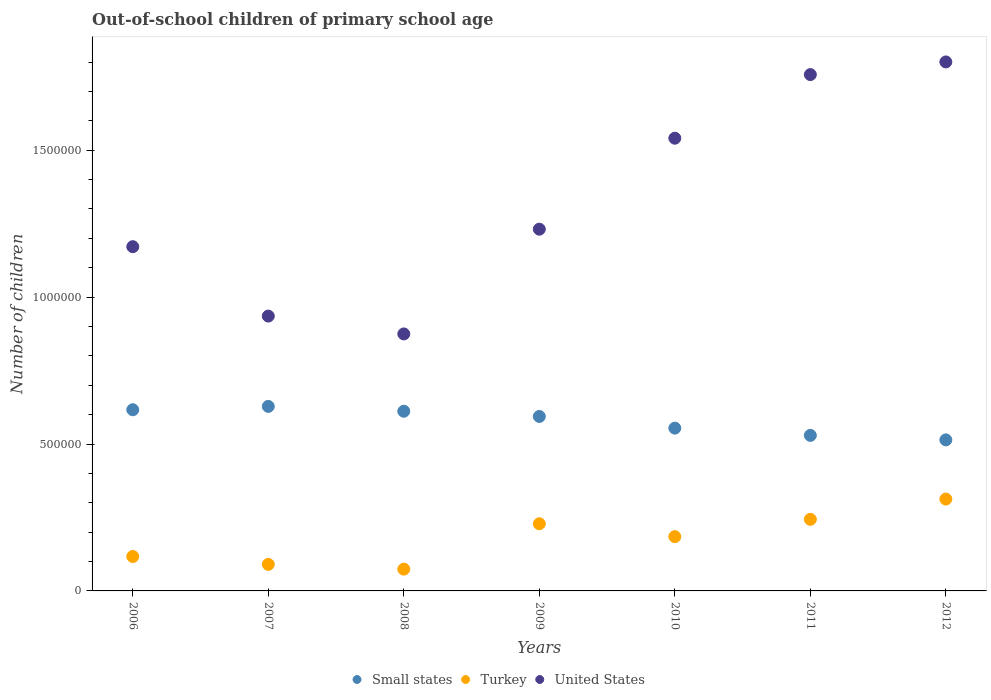Is the number of dotlines equal to the number of legend labels?
Offer a terse response. Yes. What is the number of out-of-school children in Small states in 2008?
Provide a succinct answer. 6.12e+05. Across all years, what is the maximum number of out-of-school children in United States?
Your response must be concise. 1.80e+06. Across all years, what is the minimum number of out-of-school children in Small states?
Offer a terse response. 5.14e+05. In which year was the number of out-of-school children in Small states minimum?
Provide a succinct answer. 2012. What is the total number of out-of-school children in United States in the graph?
Keep it short and to the point. 9.31e+06. What is the difference between the number of out-of-school children in Small states in 2006 and that in 2010?
Your answer should be compact. 6.25e+04. What is the difference between the number of out-of-school children in United States in 2009 and the number of out-of-school children in Small states in 2008?
Make the answer very short. 6.20e+05. What is the average number of out-of-school children in United States per year?
Offer a very short reply. 1.33e+06. In the year 2012, what is the difference between the number of out-of-school children in United States and number of out-of-school children in Small states?
Keep it short and to the point. 1.29e+06. In how many years, is the number of out-of-school children in Small states greater than 700000?
Provide a succinct answer. 0. What is the ratio of the number of out-of-school children in Small states in 2007 to that in 2011?
Your answer should be compact. 1.19. Is the number of out-of-school children in Turkey in 2011 less than that in 2012?
Your answer should be very brief. Yes. What is the difference between the highest and the second highest number of out-of-school children in United States?
Provide a short and direct response. 4.31e+04. What is the difference between the highest and the lowest number of out-of-school children in United States?
Make the answer very short. 9.26e+05. In how many years, is the number of out-of-school children in Turkey greater than the average number of out-of-school children in Turkey taken over all years?
Give a very brief answer. 4. Is the number of out-of-school children in Small states strictly greater than the number of out-of-school children in Turkey over the years?
Your response must be concise. Yes. How many years are there in the graph?
Offer a very short reply. 7. What is the difference between two consecutive major ticks on the Y-axis?
Keep it short and to the point. 5.00e+05. Are the values on the major ticks of Y-axis written in scientific E-notation?
Make the answer very short. No. Does the graph contain grids?
Your answer should be very brief. No. Where does the legend appear in the graph?
Give a very brief answer. Bottom center. How many legend labels are there?
Your answer should be compact. 3. What is the title of the graph?
Ensure brevity in your answer.  Out-of-school children of primary school age. Does "Mozambique" appear as one of the legend labels in the graph?
Ensure brevity in your answer.  No. What is the label or title of the Y-axis?
Provide a short and direct response. Number of children. What is the Number of children of Small states in 2006?
Your response must be concise. 6.17e+05. What is the Number of children of Turkey in 2006?
Your answer should be compact. 1.17e+05. What is the Number of children in United States in 2006?
Keep it short and to the point. 1.17e+06. What is the Number of children in Small states in 2007?
Provide a succinct answer. 6.28e+05. What is the Number of children in Turkey in 2007?
Offer a terse response. 9.04e+04. What is the Number of children of United States in 2007?
Offer a very short reply. 9.35e+05. What is the Number of children of Small states in 2008?
Keep it short and to the point. 6.12e+05. What is the Number of children of Turkey in 2008?
Give a very brief answer. 7.42e+04. What is the Number of children in United States in 2008?
Your answer should be very brief. 8.75e+05. What is the Number of children of Small states in 2009?
Your response must be concise. 5.94e+05. What is the Number of children of Turkey in 2009?
Offer a very short reply. 2.29e+05. What is the Number of children of United States in 2009?
Your response must be concise. 1.23e+06. What is the Number of children in Small states in 2010?
Your answer should be very brief. 5.54e+05. What is the Number of children of Turkey in 2010?
Offer a very short reply. 1.85e+05. What is the Number of children of United States in 2010?
Offer a terse response. 1.54e+06. What is the Number of children of Small states in 2011?
Provide a short and direct response. 5.29e+05. What is the Number of children of Turkey in 2011?
Give a very brief answer. 2.44e+05. What is the Number of children of United States in 2011?
Keep it short and to the point. 1.76e+06. What is the Number of children of Small states in 2012?
Provide a succinct answer. 5.14e+05. What is the Number of children in Turkey in 2012?
Ensure brevity in your answer.  3.13e+05. What is the Number of children in United States in 2012?
Your response must be concise. 1.80e+06. Across all years, what is the maximum Number of children of Small states?
Your answer should be very brief. 6.28e+05. Across all years, what is the maximum Number of children of Turkey?
Your answer should be very brief. 3.13e+05. Across all years, what is the maximum Number of children of United States?
Your answer should be compact. 1.80e+06. Across all years, what is the minimum Number of children in Small states?
Your response must be concise. 5.14e+05. Across all years, what is the minimum Number of children in Turkey?
Ensure brevity in your answer.  7.42e+04. Across all years, what is the minimum Number of children of United States?
Give a very brief answer. 8.75e+05. What is the total Number of children of Small states in the graph?
Give a very brief answer. 4.05e+06. What is the total Number of children of Turkey in the graph?
Your response must be concise. 1.25e+06. What is the total Number of children of United States in the graph?
Keep it short and to the point. 9.31e+06. What is the difference between the Number of children of Small states in 2006 and that in 2007?
Ensure brevity in your answer.  -1.14e+04. What is the difference between the Number of children in Turkey in 2006 and that in 2007?
Ensure brevity in your answer.  2.67e+04. What is the difference between the Number of children in United States in 2006 and that in 2007?
Provide a short and direct response. 2.36e+05. What is the difference between the Number of children of Small states in 2006 and that in 2008?
Ensure brevity in your answer.  5096. What is the difference between the Number of children in Turkey in 2006 and that in 2008?
Make the answer very short. 4.29e+04. What is the difference between the Number of children in United States in 2006 and that in 2008?
Provide a short and direct response. 2.97e+05. What is the difference between the Number of children of Small states in 2006 and that in 2009?
Make the answer very short. 2.28e+04. What is the difference between the Number of children of Turkey in 2006 and that in 2009?
Offer a very short reply. -1.11e+05. What is the difference between the Number of children in United States in 2006 and that in 2009?
Your answer should be very brief. -5.96e+04. What is the difference between the Number of children in Small states in 2006 and that in 2010?
Keep it short and to the point. 6.25e+04. What is the difference between the Number of children in Turkey in 2006 and that in 2010?
Provide a short and direct response. -6.77e+04. What is the difference between the Number of children in United States in 2006 and that in 2010?
Offer a terse response. -3.69e+05. What is the difference between the Number of children in Small states in 2006 and that in 2011?
Your response must be concise. 8.72e+04. What is the difference between the Number of children in Turkey in 2006 and that in 2011?
Your response must be concise. -1.27e+05. What is the difference between the Number of children in United States in 2006 and that in 2011?
Make the answer very short. -5.86e+05. What is the difference between the Number of children in Small states in 2006 and that in 2012?
Give a very brief answer. 1.03e+05. What is the difference between the Number of children of Turkey in 2006 and that in 2012?
Offer a very short reply. -1.96e+05. What is the difference between the Number of children of United States in 2006 and that in 2012?
Provide a succinct answer. -6.29e+05. What is the difference between the Number of children of Small states in 2007 and that in 2008?
Keep it short and to the point. 1.65e+04. What is the difference between the Number of children of Turkey in 2007 and that in 2008?
Give a very brief answer. 1.62e+04. What is the difference between the Number of children of United States in 2007 and that in 2008?
Offer a very short reply. 6.08e+04. What is the difference between the Number of children of Small states in 2007 and that in 2009?
Provide a succinct answer. 3.42e+04. What is the difference between the Number of children of Turkey in 2007 and that in 2009?
Keep it short and to the point. -1.38e+05. What is the difference between the Number of children in United States in 2007 and that in 2009?
Offer a terse response. -2.96e+05. What is the difference between the Number of children in Small states in 2007 and that in 2010?
Provide a succinct answer. 7.39e+04. What is the difference between the Number of children of Turkey in 2007 and that in 2010?
Ensure brevity in your answer.  -9.43e+04. What is the difference between the Number of children in United States in 2007 and that in 2010?
Your response must be concise. -6.05e+05. What is the difference between the Number of children in Small states in 2007 and that in 2011?
Provide a succinct answer. 9.86e+04. What is the difference between the Number of children of Turkey in 2007 and that in 2011?
Provide a succinct answer. -1.53e+05. What is the difference between the Number of children of United States in 2007 and that in 2011?
Keep it short and to the point. -8.22e+05. What is the difference between the Number of children in Small states in 2007 and that in 2012?
Ensure brevity in your answer.  1.14e+05. What is the difference between the Number of children of Turkey in 2007 and that in 2012?
Keep it short and to the point. -2.22e+05. What is the difference between the Number of children of United States in 2007 and that in 2012?
Give a very brief answer. -8.65e+05. What is the difference between the Number of children in Small states in 2008 and that in 2009?
Offer a very short reply. 1.77e+04. What is the difference between the Number of children of Turkey in 2008 and that in 2009?
Give a very brief answer. -1.54e+05. What is the difference between the Number of children of United States in 2008 and that in 2009?
Make the answer very short. -3.57e+05. What is the difference between the Number of children in Small states in 2008 and that in 2010?
Your answer should be compact. 5.74e+04. What is the difference between the Number of children in Turkey in 2008 and that in 2010?
Give a very brief answer. -1.11e+05. What is the difference between the Number of children in United States in 2008 and that in 2010?
Provide a succinct answer. -6.66e+05. What is the difference between the Number of children in Small states in 2008 and that in 2011?
Ensure brevity in your answer.  8.22e+04. What is the difference between the Number of children in Turkey in 2008 and that in 2011?
Offer a very short reply. -1.70e+05. What is the difference between the Number of children in United States in 2008 and that in 2011?
Your response must be concise. -8.83e+05. What is the difference between the Number of children of Small states in 2008 and that in 2012?
Make the answer very short. 9.74e+04. What is the difference between the Number of children of Turkey in 2008 and that in 2012?
Give a very brief answer. -2.39e+05. What is the difference between the Number of children in United States in 2008 and that in 2012?
Make the answer very short. -9.26e+05. What is the difference between the Number of children of Small states in 2009 and that in 2010?
Your answer should be compact. 3.97e+04. What is the difference between the Number of children in Turkey in 2009 and that in 2010?
Provide a succinct answer. 4.38e+04. What is the difference between the Number of children in United States in 2009 and that in 2010?
Make the answer very short. -3.10e+05. What is the difference between the Number of children in Small states in 2009 and that in 2011?
Your answer should be very brief. 6.44e+04. What is the difference between the Number of children in Turkey in 2009 and that in 2011?
Give a very brief answer. -1.52e+04. What is the difference between the Number of children of United States in 2009 and that in 2011?
Provide a short and direct response. -5.26e+05. What is the difference between the Number of children in Small states in 2009 and that in 2012?
Keep it short and to the point. 7.97e+04. What is the difference between the Number of children of Turkey in 2009 and that in 2012?
Keep it short and to the point. -8.41e+04. What is the difference between the Number of children of United States in 2009 and that in 2012?
Make the answer very short. -5.69e+05. What is the difference between the Number of children of Small states in 2010 and that in 2011?
Give a very brief answer. 2.47e+04. What is the difference between the Number of children in Turkey in 2010 and that in 2011?
Give a very brief answer. -5.90e+04. What is the difference between the Number of children in United States in 2010 and that in 2011?
Ensure brevity in your answer.  -2.17e+05. What is the difference between the Number of children in Small states in 2010 and that in 2012?
Your answer should be compact. 4.00e+04. What is the difference between the Number of children in Turkey in 2010 and that in 2012?
Offer a terse response. -1.28e+05. What is the difference between the Number of children of United States in 2010 and that in 2012?
Your answer should be compact. -2.60e+05. What is the difference between the Number of children in Small states in 2011 and that in 2012?
Your response must be concise. 1.53e+04. What is the difference between the Number of children of Turkey in 2011 and that in 2012?
Offer a terse response. -6.89e+04. What is the difference between the Number of children of United States in 2011 and that in 2012?
Your answer should be compact. -4.31e+04. What is the difference between the Number of children in Small states in 2006 and the Number of children in Turkey in 2007?
Provide a short and direct response. 5.26e+05. What is the difference between the Number of children in Small states in 2006 and the Number of children in United States in 2007?
Your response must be concise. -3.19e+05. What is the difference between the Number of children in Turkey in 2006 and the Number of children in United States in 2007?
Make the answer very short. -8.18e+05. What is the difference between the Number of children of Small states in 2006 and the Number of children of Turkey in 2008?
Make the answer very short. 5.42e+05. What is the difference between the Number of children of Small states in 2006 and the Number of children of United States in 2008?
Your response must be concise. -2.58e+05. What is the difference between the Number of children of Turkey in 2006 and the Number of children of United States in 2008?
Provide a short and direct response. -7.58e+05. What is the difference between the Number of children in Small states in 2006 and the Number of children in Turkey in 2009?
Make the answer very short. 3.88e+05. What is the difference between the Number of children in Small states in 2006 and the Number of children in United States in 2009?
Keep it short and to the point. -6.15e+05. What is the difference between the Number of children of Turkey in 2006 and the Number of children of United States in 2009?
Offer a very short reply. -1.11e+06. What is the difference between the Number of children of Small states in 2006 and the Number of children of Turkey in 2010?
Offer a very short reply. 4.32e+05. What is the difference between the Number of children of Small states in 2006 and the Number of children of United States in 2010?
Offer a terse response. -9.24e+05. What is the difference between the Number of children of Turkey in 2006 and the Number of children of United States in 2010?
Offer a very short reply. -1.42e+06. What is the difference between the Number of children of Small states in 2006 and the Number of children of Turkey in 2011?
Offer a very short reply. 3.73e+05. What is the difference between the Number of children of Small states in 2006 and the Number of children of United States in 2011?
Your response must be concise. -1.14e+06. What is the difference between the Number of children in Turkey in 2006 and the Number of children in United States in 2011?
Your answer should be very brief. -1.64e+06. What is the difference between the Number of children of Small states in 2006 and the Number of children of Turkey in 2012?
Provide a short and direct response. 3.04e+05. What is the difference between the Number of children of Small states in 2006 and the Number of children of United States in 2012?
Offer a very short reply. -1.18e+06. What is the difference between the Number of children in Turkey in 2006 and the Number of children in United States in 2012?
Offer a very short reply. -1.68e+06. What is the difference between the Number of children of Small states in 2007 and the Number of children of Turkey in 2008?
Provide a succinct answer. 5.54e+05. What is the difference between the Number of children of Small states in 2007 and the Number of children of United States in 2008?
Provide a short and direct response. -2.47e+05. What is the difference between the Number of children of Turkey in 2007 and the Number of children of United States in 2008?
Offer a terse response. -7.84e+05. What is the difference between the Number of children of Small states in 2007 and the Number of children of Turkey in 2009?
Make the answer very short. 3.99e+05. What is the difference between the Number of children in Small states in 2007 and the Number of children in United States in 2009?
Provide a short and direct response. -6.03e+05. What is the difference between the Number of children in Turkey in 2007 and the Number of children in United States in 2009?
Your answer should be very brief. -1.14e+06. What is the difference between the Number of children of Small states in 2007 and the Number of children of Turkey in 2010?
Your answer should be very brief. 4.43e+05. What is the difference between the Number of children in Small states in 2007 and the Number of children in United States in 2010?
Your response must be concise. -9.13e+05. What is the difference between the Number of children of Turkey in 2007 and the Number of children of United States in 2010?
Offer a terse response. -1.45e+06. What is the difference between the Number of children in Small states in 2007 and the Number of children in Turkey in 2011?
Your response must be concise. 3.84e+05. What is the difference between the Number of children in Small states in 2007 and the Number of children in United States in 2011?
Provide a succinct answer. -1.13e+06. What is the difference between the Number of children in Turkey in 2007 and the Number of children in United States in 2011?
Your answer should be compact. -1.67e+06. What is the difference between the Number of children of Small states in 2007 and the Number of children of Turkey in 2012?
Offer a very short reply. 3.15e+05. What is the difference between the Number of children in Small states in 2007 and the Number of children in United States in 2012?
Provide a short and direct response. -1.17e+06. What is the difference between the Number of children of Turkey in 2007 and the Number of children of United States in 2012?
Offer a very short reply. -1.71e+06. What is the difference between the Number of children in Small states in 2008 and the Number of children in Turkey in 2009?
Provide a succinct answer. 3.83e+05. What is the difference between the Number of children of Small states in 2008 and the Number of children of United States in 2009?
Offer a very short reply. -6.20e+05. What is the difference between the Number of children of Turkey in 2008 and the Number of children of United States in 2009?
Provide a succinct answer. -1.16e+06. What is the difference between the Number of children of Small states in 2008 and the Number of children of Turkey in 2010?
Make the answer very short. 4.27e+05. What is the difference between the Number of children in Small states in 2008 and the Number of children in United States in 2010?
Provide a short and direct response. -9.29e+05. What is the difference between the Number of children in Turkey in 2008 and the Number of children in United States in 2010?
Offer a terse response. -1.47e+06. What is the difference between the Number of children in Small states in 2008 and the Number of children in Turkey in 2011?
Offer a very short reply. 3.68e+05. What is the difference between the Number of children in Small states in 2008 and the Number of children in United States in 2011?
Provide a short and direct response. -1.15e+06. What is the difference between the Number of children in Turkey in 2008 and the Number of children in United States in 2011?
Provide a succinct answer. -1.68e+06. What is the difference between the Number of children in Small states in 2008 and the Number of children in Turkey in 2012?
Your answer should be very brief. 2.99e+05. What is the difference between the Number of children in Small states in 2008 and the Number of children in United States in 2012?
Offer a terse response. -1.19e+06. What is the difference between the Number of children in Turkey in 2008 and the Number of children in United States in 2012?
Give a very brief answer. -1.73e+06. What is the difference between the Number of children in Small states in 2009 and the Number of children in Turkey in 2010?
Offer a terse response. 4.09e+05. What is the difference between the Number of children in Small states in 2009 and the Number of children in United States in 2010?
Offer a very short reply. -9.47e+05. What is the difference between the Number of children of Turkey in 2009 and the Number of children of United States in 2010?
Make the answer very short. -1.31e+06. What is the difference between the Number of children of Small states in 2009 and the Number of children of Turkey in 2011?
Ensure brevity in your answer.  3.50e+05. What is the difference between the Number of children in Small states in 2009 and the Number of children in United States in 2011?
Make the answer very short. -1.16e+06. What is the difference between the Number of children of Turkey in 2009 and the Number of children of United States in 2011?
Ensure brevity in your answer.  -1.53e+06. What is the difference between the Number of children in Small states in 2009 and the Number of children in Turkey in 2012?
Keep it short and to the point. 2.81e+05. What is the difference between the Number of children of Small states in 2009 and the Number of children of United States in 2012?
Your answer should be very brief. -1.21e+06. What is the difference between the Number of children in Turkey in 2009 and the Number of children in United States in 2012?
Your response must be concise. -1.57e+06. What is the difference between the Number of children of Small states in 2010 and the Number of children of Turkey in 2011?
Your answer should be compact. 3.10e+05. What is the difference between the Number of children of Small states in 2010 and the Number of children of United States in 2011?
Your answer should be very brief. -1.20e+06. What is the difference between the Number of children of Turkey in 2010 and the Number of children of United States in 2011?
Provide a succinct answer. -1.57e+06. What is the difference between the Number of children of Small states in 2010 and the Number of children of Turkey in 2012?
Your answer should be compact. 2.41e+05. What is the difference between the Number of children of Small states in 2010 and the Number of children of United States in 2012?
Your answer should be very brief. -1.25e+06. What is the difference between the Number of children of Turkey in 2010 and the Number of children of United States in 2012?
Ensure brevity in your answer.  -1.62e+06. What is the difference between the Number of children of Small states in 2011 and the Number of children of Turkey in 2012?
Your answer should be compact. 2.17e+05. What is the difference between the Number of children in Small states in 2011 and the Number of children in United States in 2012?
Provide a succinct answer. -1.27e+06. What is the difference between the Number of children in Turkey in 2011 and the Number of children in United States in 2012?
Ensure brevity in your answer.  -1.56e+06. What is the average Number of children in Small states per year?
Offer a terse response. 5.78e+05. What is the average Number of children of Turkey per year?
Your response must be concise. 1.79e+05. What is the average Number of children of United States per year?
Your answer should be compact. 1.33e+06. In the year 2006, what is the difference between the Number of children of Small states and Number of children of Turkey?
Offer a terse response. 5.00e+05. In the year 2006, what is the difference between the Number of children in Small states and Number of children in United States?
Give a very brief answer. -5.55e+05. In the year 2006, what is the difference between the Number of children in Turkey and Number of children in United States?
Your response must be concise. -1.05e+06. In the year 2007, what is the difference between the Number of children of Small states and Number of children of Turkey?
Your answer should be very brief. 5.38e+05. In the year 2007, what is the difference between the Number of children in Small states and Number of children in United States?
Offer a terse response. -3.07e+05. In the year 2007, what is the difference between the Number of children of Turkey and Number of children of United States?
Your response must be concise. -8.45e+05. In the year 2008, what is the difference between the Number of children in Small states and Number of children in Turkey?
Provide a short and direct response. 5.37e+05. In the year 2008, what is the difference between the Number of children of Small states and Number of children of United States?
Offer a very short reply. -2.63e+05. In the year 2008, what is the difference between the Number of children of Turkey and Number of children of United States?
Offer a very short reply. -8.00e+05. In the year 2009, what is the difference between the Number of children of Small states and Number of children of Turkey?
Your answer should be very brief. 3.65e+05. In the year 2009, what is the difference between the Number of children of Small states and Number of children of United States?
Offer a terse response. -6.37e+05. In the year 2009, what is the difference between the Number of children in Turkey and Number of children in United States?
Offer a terse response. -1.00e+06. In the year 2010, what is the difference between the Number of children of Small states and Number of children of Turkey?
Offer a very short reply. 3.69e+05. In the year 2010, what is the difference between the Number of children in Small states and Number of children in United States?
Your response must be concise. -9.87e+05. In the year 2010, what is the difference between the Number of children in Turkey and Number of children in United States?
Provide a succinct answer. -1.36e+06. In the year 2011, what is the difference between the Number of children of Small states and Number of children of Turkey?
Offer a terse response. 2.86e+05. In the year 2011, what is the difference between the Number of children of Small states and Number of children of United States?
Offer a terse response. -1.23e+06. In the year 2011, what is the difference between the Number of children in Turkey and Number of children in United States?
Give a very brief answer. -1.51e+06. In the year 2012, what is the difference between the Number of children in Small states and Number of children in Turkey?
Make the answer very short. 2.01e+05. In the year 2012, what is the difference between the Number of children in Small states and Number of children in United States?
Provide a succinct answer. -1.29e+06. In the year 2012, what is the difference between the Number of children of Turkey and Number of children of United States?
Provide a short and direct response. -1.49e+06. What is the ratio of the Number of children in Small states in 2006 to that in 2007?
Your response must be concise. 0.98. What is the ratio of the Number of children in Turkey in 2006 to that in 2007?
Ensure brevity in your answer.  1.3. What is the ratio of the Number of children in United States in 2006 to that in 2007?
Make the answer very short. 1.25. What is the ratio of the Number of children in Small states in 2006 to that in 2008?
Provide a short and direct response. 1.01. What is the ratio of the Number of children in Turkey in 2006 to that in 2008?
Offer a very short reply. 1.58. What is the ratio of the Number of children in United States in 2006 to that in 2008?
Your answer should be very brief. 1.34. What is the ratio of the Number of children of Turkey in 2006 to that in 2009?
Provide a succinct answer. 0.51. What is the ratio of the Number of children of United States in 2006 to that in 2009?
Provide a short and direct response. 0.95. What is the ratio of the Number of children of Small states in 2006 to that in 2010?
Your answer should be compact. 1.11. What is the ratio of the Number of children in Turkey in 2006 to that in 2010?
Provide a succinct answer. 0.63. What is the ratio of the Number of children in United States in 2006 to that in 2010?
Your response must be concise. 0.76. What is the ratio of the Number of children in Small states in 2006 to that in 2011?
Your response must be concise. 1.16. What is the ratio of the Number of children in Turkey in 2006 to that in 2011?
Your answer should be compact. 0.48. What is the ratio of the Number of children in Small states in 2006 to that in 2012?
Ensure brevity in your answer.  1.2. What is the ratio of the Number of children in Turkey in 2006 to that in 2012?
Ensure brevity in your answer.  0.37. What is the ratio of the Number of children in United States in 2006 to that in 2012?
Ensure brevity in your answer.  0.65. What is the ratio of the Number of children in Small states in 2007 to that in 2008?
Your answer should be very brief. 1.03. What is the ratio of the Number of children of Turkey in 2007 to that in 2008?
Make the answer very short. 1.22. What is the ratio of the Number of children in United States in 2007 to that in 2008?
Your answer should be very brief. 1.07. What is the ratio of the Number of children of Small states in 2007 to that in 2009?
Your answer should be compact. 1.06. What is the ratio of the Number of children in Turkey in 2007 to that in 2009?
Provide a succinct answer. 0.4. What is the ratio of the Number of children in United States in 2007 to that in 2009?
Make the answer very short. 0.76. What is the ratio of the Number of children of Small states in 2007 to that in 2010?
Your response must be concise. 1.13. What is the ratio of the Number of children of Turkey in 2007 to that in 2010?
Your answer should be compact. 0.49. What is the ratio of the Number of children of United States in 2007 to that in 2010?
Give a very brief answer. 0.61. What is the ratio of the Number of children in Small states in 2007 to that in 2011?
Give a very brief answer. 1.19. What is the ratio of the Number of children of Turkey in 2007 to that in 2011?
Keep it short and to the point. 0.37. What is the ratio of the Number of children in United States in 2007 to that in 2011?
Give a very brief answer. 0.53. What is the ratio of the Number of children in Small states in 2007 to that in 2012?
Your response must be concise. 1.22. What is the ratio of the Number of children of Turkey in 2007 to that in 2012?
Provide a short and direct response. 0.29. What is the ratio of the Number of children of United States in 2007 to that in 2012?
Provide a succinct answer. 0.52. What is the ratio of the Number of children of Small states in 2008 to that in 2009?
Your response must be concise. 1.03. What is the ratio of the Number of children in Turkey in 2008 to that in 2009?
Make the answer very short. 0.32. What is the ratio of the Number of children in United States in 2008 to that in 2009?
Provide a short and direct response. 0.71. What is the ratio of the Number of children in Small states in 2008 to that in 2010?
Offer a terse response. 1.1. What is the ratio of the Number of children in Turkey in 2008 to that in 2010?
Keep it short and to the point. 0.4. What is the ratio of the Number of children of United States in 2008 to that in 2010?
Your answer should be compact. 0.57. What is the ratio of the Number of children of Small states in 2008 to that in 2011?
Keep it short and to the point. 1.16. What is the ratio of the Number of children of Turkey in 2008 to that in 2011?
Provide a succinct answer. 0.3. What is the ratio of the Number of children in United States in 2008 to that in 2011?
Offer a terse response. 0.5. What is the ratio of the Number of children in Small states in 2008 to that in 2012?
Make the answer very short. 1.19. What is the ratio of the Number of children in Turkey in 2008 to that in 2012?
Your response must be concise. 0.24. What is the ratio of the Number of children in United States in 2008 to that in 2012?
Give a very brief answer. 0.49. What is the ratio of the Number of children in Small states in 2009 to that in 2010?
Your answer should be very brief. 1.07. What is the ratio of the Number of children in Turkey in 2009 to that in 2010?
Offer a terse response. 1.24. What is the ratio of the Number of children in United States in 2009 to that in 2010?
Ensure brevity in your answer.  0.8. What is the ratio of the Number of children of Small states in 2009 to that in 2011?
Your response must be concise. 1.12. What is the ratio of the Number of children in Turkey in 2009 to that in 2011?
Ensure brevity in your answer.  0.94. What is the ratio of the Number of children in United States in 2009 to that in 2011?
Provide a short and direct response. 0.7. What is the ratio of the Number of children of Small states in 2009 to that in 2012?
Make the answer very short. 1.16. What is the ratio of the Number of children of Turkey in 2009 to that in 2012?
Make the answer very short. 0.73. What is the ratio of the Number of children of United States in 2009 to that in 2012?
Give a very brief answer. 0.68. What is the ratio of the Number of children in Small states in 2010 to that in 2011?
Offer a very short reply. 1.05. What is the ratio of the Number of children in Turkey in 2010 to that in 2011?
Make the answer very short. 0.76. What is the ratio of the Number of children in United States in 2010 to that in 2011?
Offer a very short reply. 0.88. What is the ratio of the Number of children in Small states in 2010 to that in 2012?
Ensure brevity in your answer.  1.08. What is the ratio of the Number of children of Turkey in 2010 to that in 2012?
Your answer should be compact. 0.59. What is the ratio of the Number of children of United States in 2010 to that in 2012?
Provide a short and direct response. 0.86. What is the ratio of the Number of children in Small states in 2011 to that in 2012?
Offer a terse response. 1.03. What is the ratio of the Number of children in Turkey in 2011 to that in 2012?
Your answer should be compact. 0.78. What is the ratio of the Number of children of United States in 2011 to that in 2012?
Your answer should be very brief. 0.98. What is the difference between the highest and the second highest Number of children of Small states?
Provide a short and direct response. 1.14e+04. What is the difference between the highest and the second highest Number of children in Turkey?
Give a very brief answer. 6.89e+04. What is the difference between the highest and the second highest Number of children in United States?
Give a very brief answer. 4.31e+04. What is the difference between the highest and the lowest Number of children in Small states?
Provide a short and direct response. 1.14e+05. What is the difference between the highest and the lowest Number of children of Turkey?
Your answer should be compact. 2.39e+05. What is the difference between the highest and the lowest Number of children in United States?
Provide a short and direct response. 9.26e+05. 